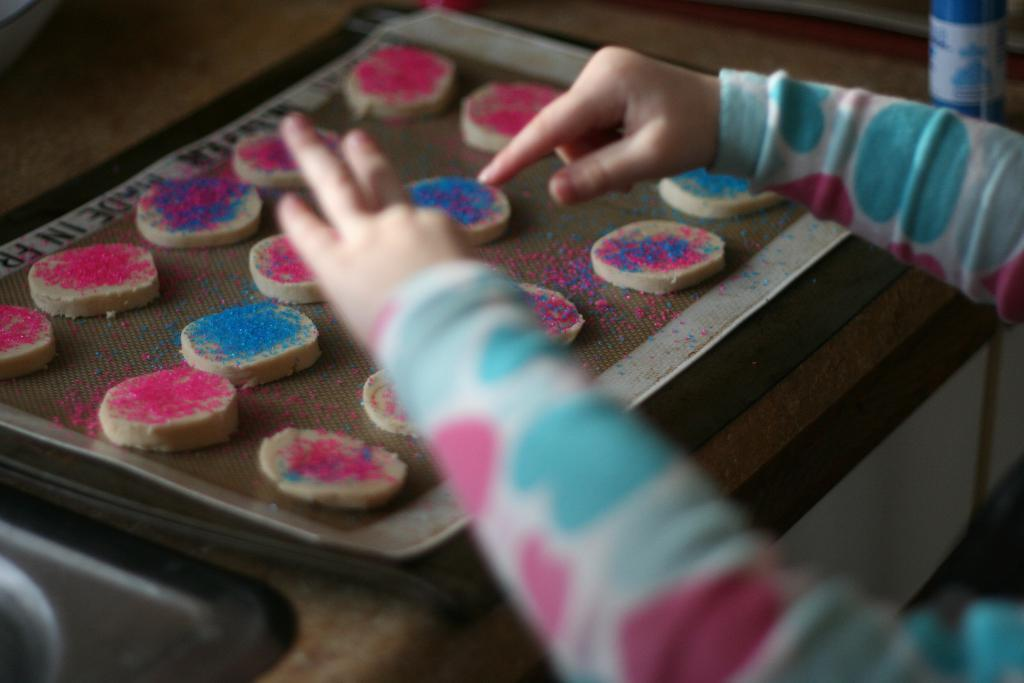What is located in the center of the image? There are clays in the center of the image. Can you describe any other elements in the image? Yes, there is a hand of a person in the image. What is the price of the pie in the image? There is no pie present in the image, so it is not possible to determine its price. 